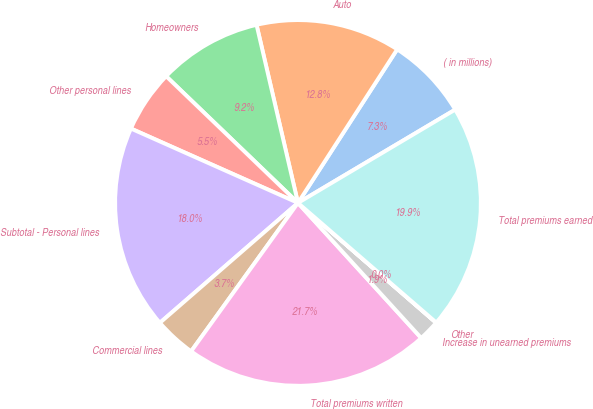<chart> <loc_0><loc_0><loc_500><loc_500><pie_chart><fcel>( in millions)<fcel>Auto<fcel>Homeowners<fcel>Other personal lines<fcel>Subtotal - Personal lines<fcel>Commercial lines<fcel>Total premiums written<fcel>Increase in unearned premiums<fcel>Other<fcel>Total premiums earned<nl><fcel>7.35%<fcel>12.77%<fcel>9.18%<fcel>5.52%<fcel>18.05%<fcel>3.69%<fcel>21.71%<fcel>1.86%<fcel>0.02%<fcel>19.88%<nl></chart> 